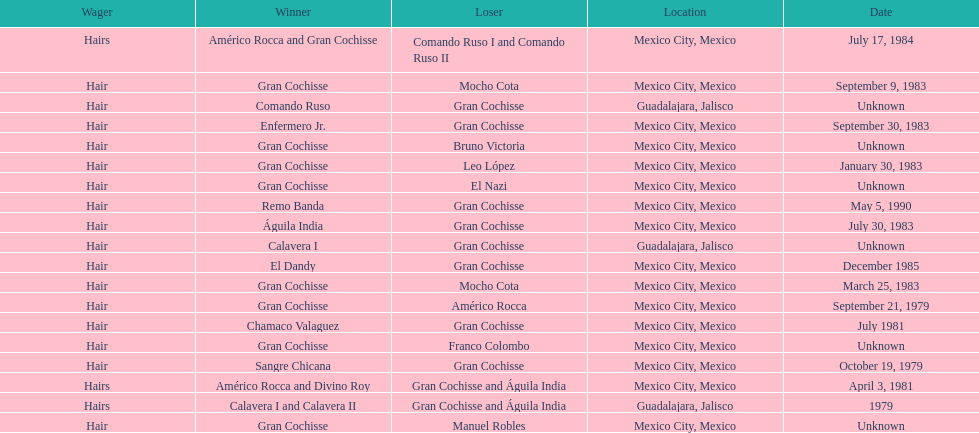When was gran chochisse first match that had a full date on record? September 21, 1979. 